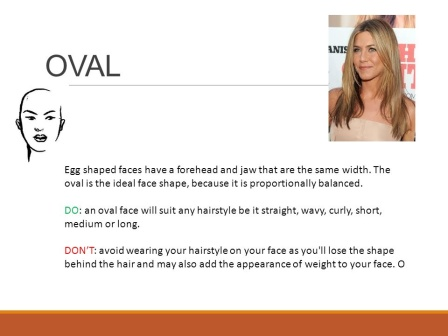What do you think is going on in this snapshot? The image appears to be a well-organized educational slide from a beauty or hairstyle seminar. It features a sectioned layout with an illustrated diagram of an oval face shape on the left and a real-life application using a photograph of a woman with a similar face shape on the right. The slide comprehensively discusses the characteristics of an oval face shape and suggests various hairstyles that are deemed suitable, highlighting the versatility of this face shape with style options ranging from straight to curly and short to long. The slide not only informs about the dos but also advises against certain styles that might not flatter this face shape, providing a holistic educational resource for hairstylists or individuals interested in understanding how to enhance natural facial features. 